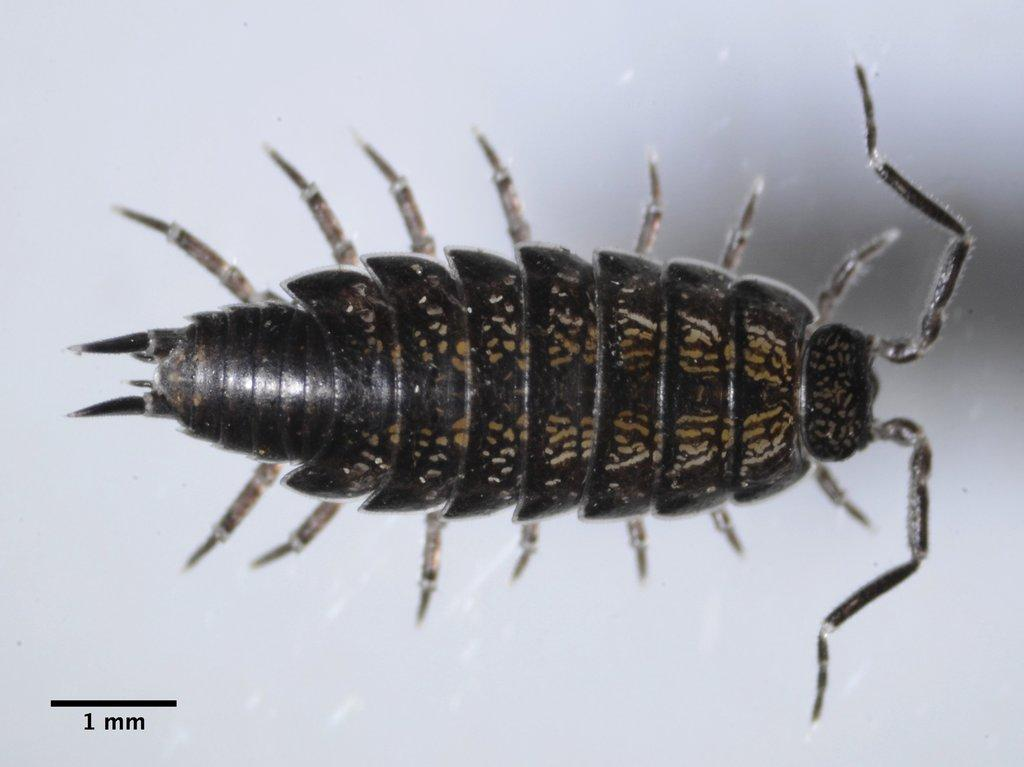What type of creature can be seen in the image? There is an insect in the image. What is located in the bottom left corner of the image? There is text in the bottom left corner of the image. What color is the background of the image? The background of the image is white. What type of brush is being used to clean the engine in the image? There is no brush or engine present in the image; it features an insect and text on a white background. 